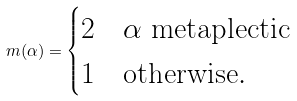Convert formula to latex. <formula><loc_0><loc_0><loc_500><loc_500>m ( \alpha ) = \begin{cases} 2 & \alpha \text { metaplectic} \\ 1 & \text {otherwise} . \end{cases}</formula> 